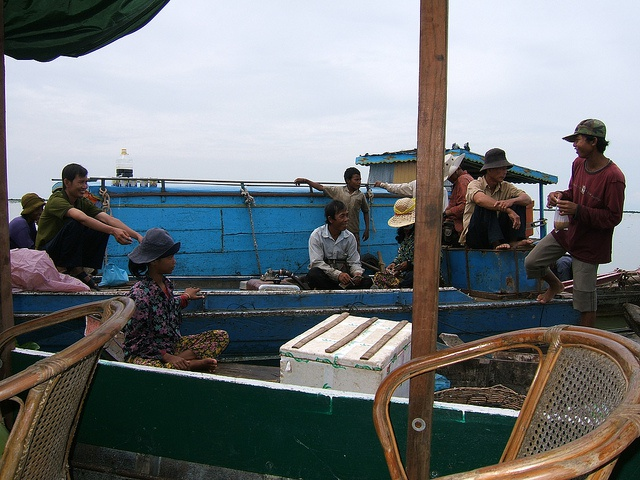Describe the objects in this image and their specific colors. I can see boat in black, maroon, and lightgray tones, chair in black, gray, and maroon tones, boat in black, teal, blue, and gray tones, boat in black, navy, gray, and blue tones, and chair in black, maroon, and gray tones in this image. 